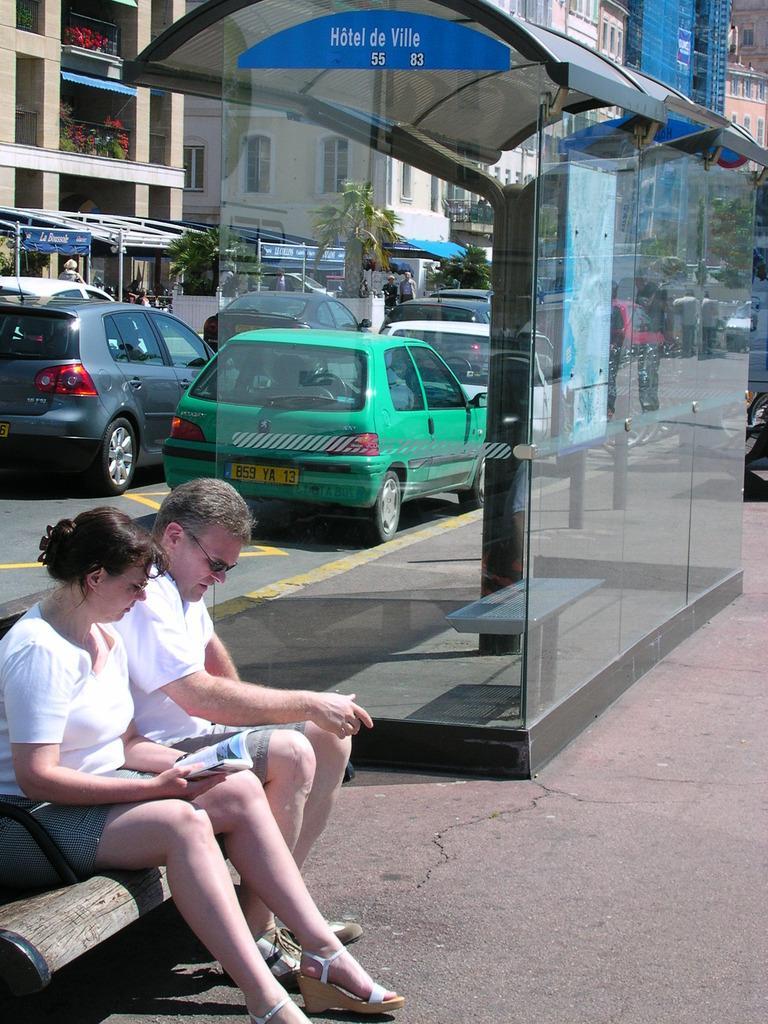Can you describe this image briefly? This picture is clicked outside. In the foreground we can see the two people wearing white color T-shirts and sitting on the bench and we can see the book. In the center we can see a shed and the bench and we can see the cars seems to be running on the road and we can see the group of people. In the background we can see the buildings, trees, metal rods, tents and some other items. 